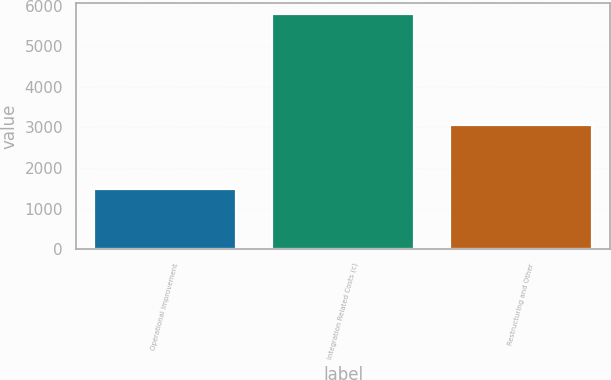<chart> <loc_0><loc_0><loc_500><loc_500><bar_chart><fcel>Operational Improvement<fcel>Integration Related Costs (c)<fcel>Restructuring and Other<nl><fcel>1475<fcel>5791<fcel>3066<nl></chart> 